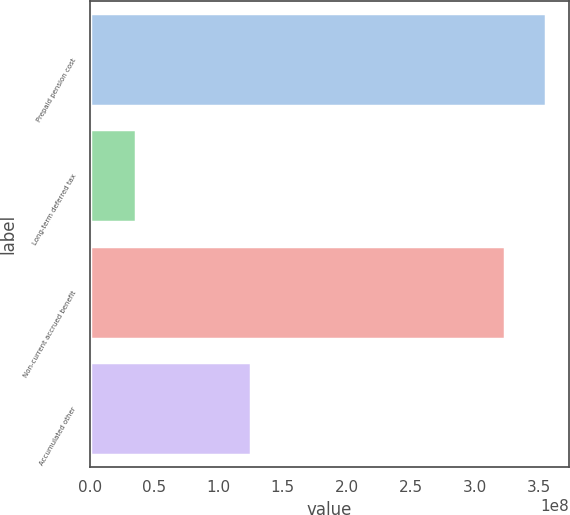<chart> <loc_0><loc_0><loc_500><loc_500><bar_chart><fcel>Prepaid pension cost<fcel>Long-term deferred tax<fcel>Non-current accrued benefit<fcel>Accumulated other<nl><fcel>3.55384e+08<fcel>3.5132e+07<fcel>3.23658e+08<fcel>1.25265e+08<nl></chart> 